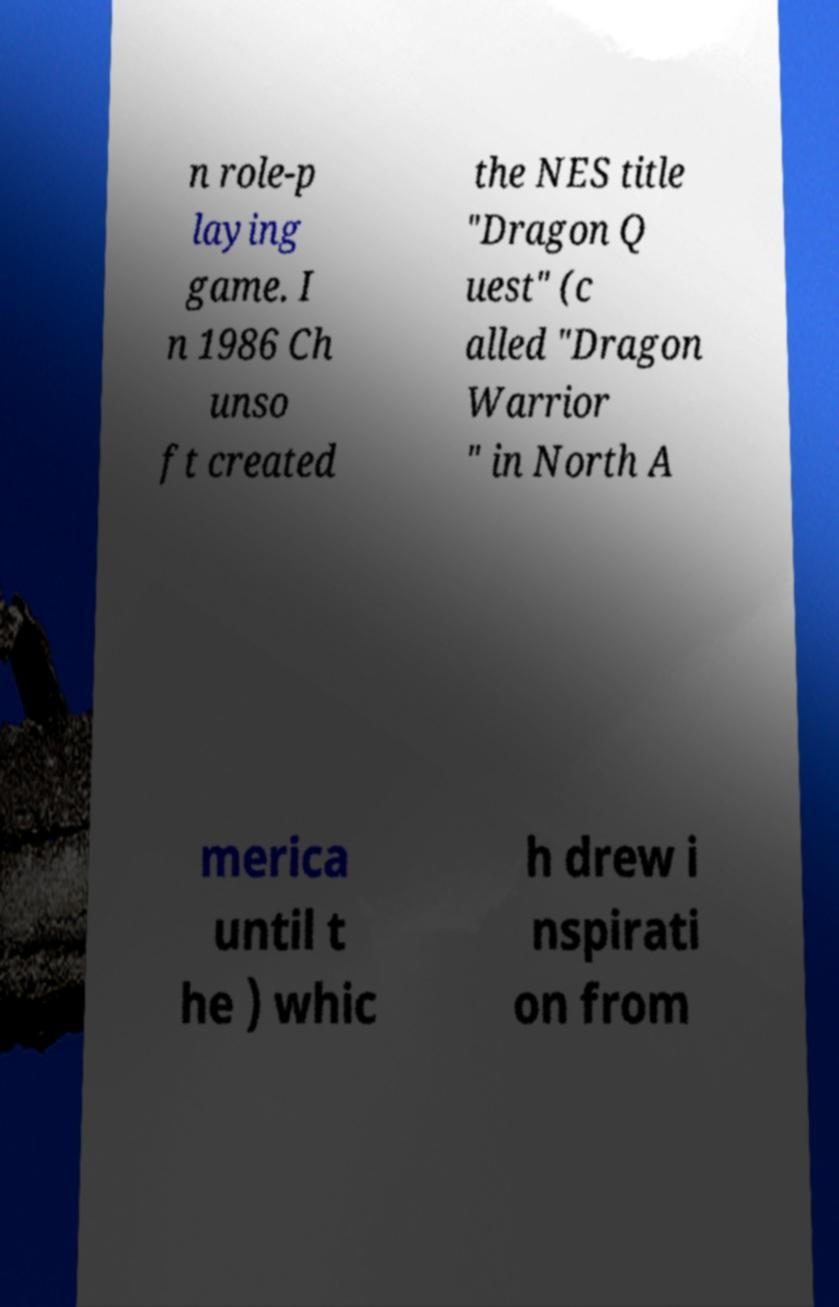Please read and relay the text visible in this image. What does it say? n role-p laying game. I n 1986 Ch unso ft created the NES title "Dragon Q uest" (c alled "Dragon Warrior " in North A merica until t he ) whic h drew i nspirati on from 